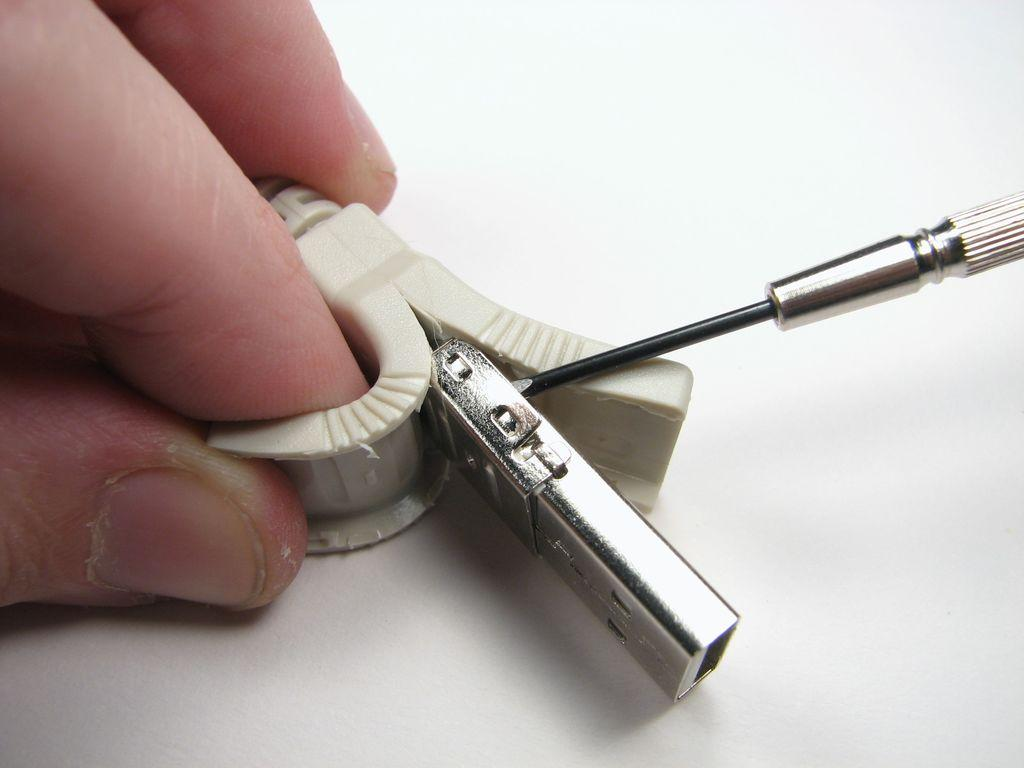What is the main subject of the image? There is an object in the image. Can you describe the appearance of the object? The object is white and silver in color. What part of a person is visible in the object? A person's finger is visible in the object. How many boys are sitting on the chairs in the airport depicted in the image? There is no image of an airport or chairs with boys in this image; it only features an object with a person's finger visible. 